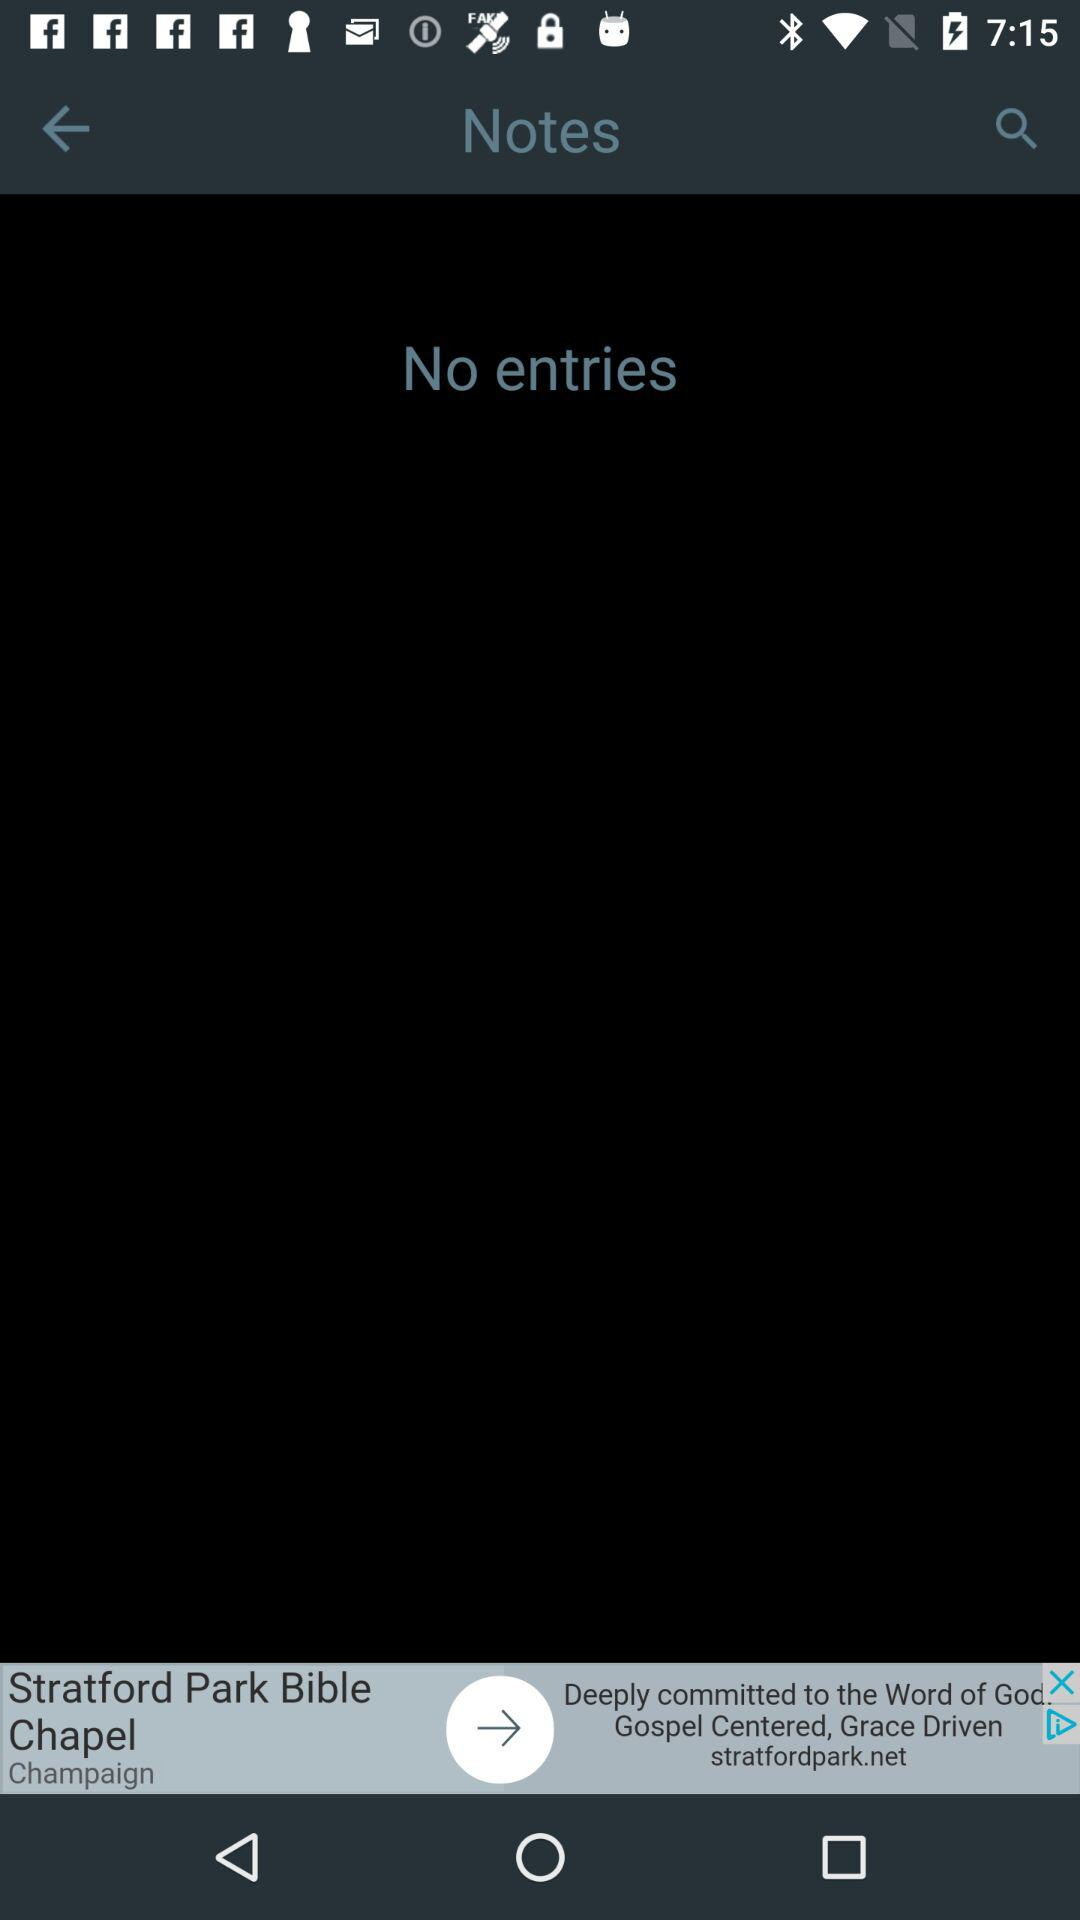How many entries are in the notes? There are no entries. 